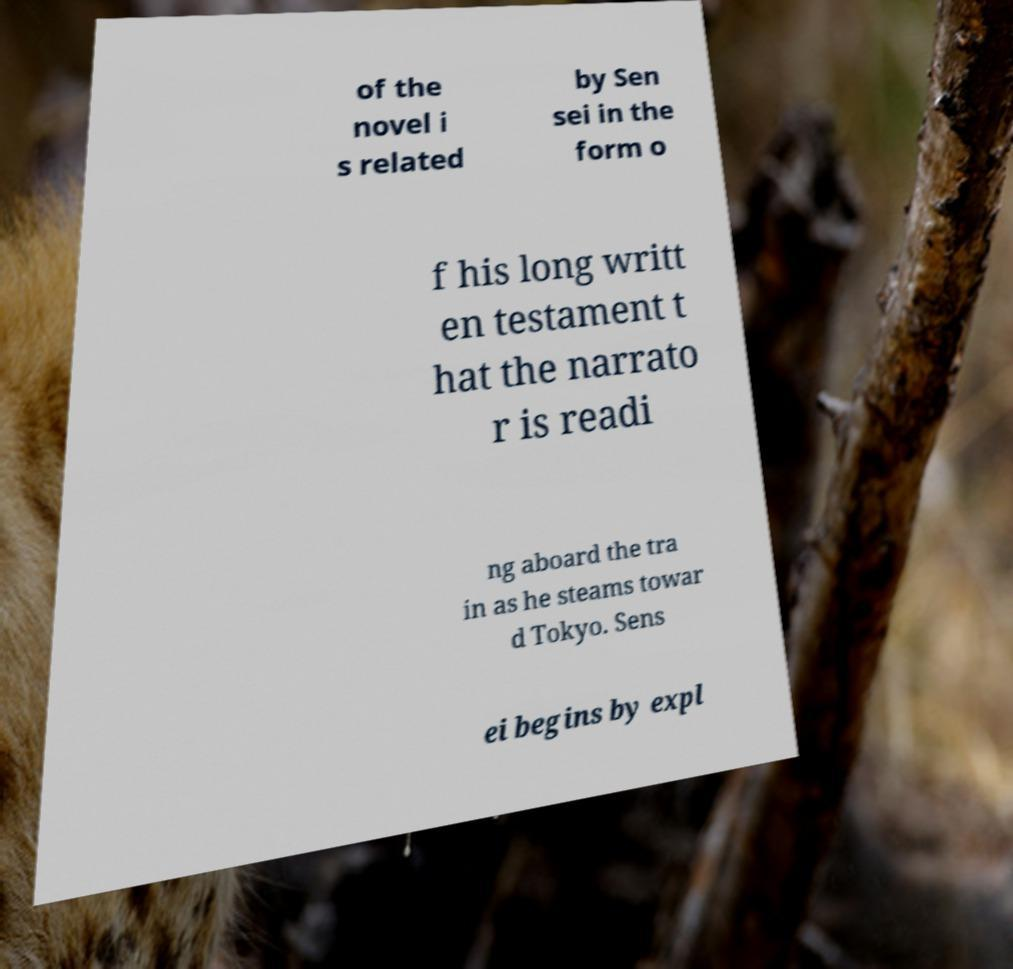Please identify and transcribe the text found in this image. of the novel i s related by Sen sei in the form o f his long writt en testament t hat the narrato r is readi ng aboard the tra in as he steams towar d Tokyo. Sens ei begins by expl 